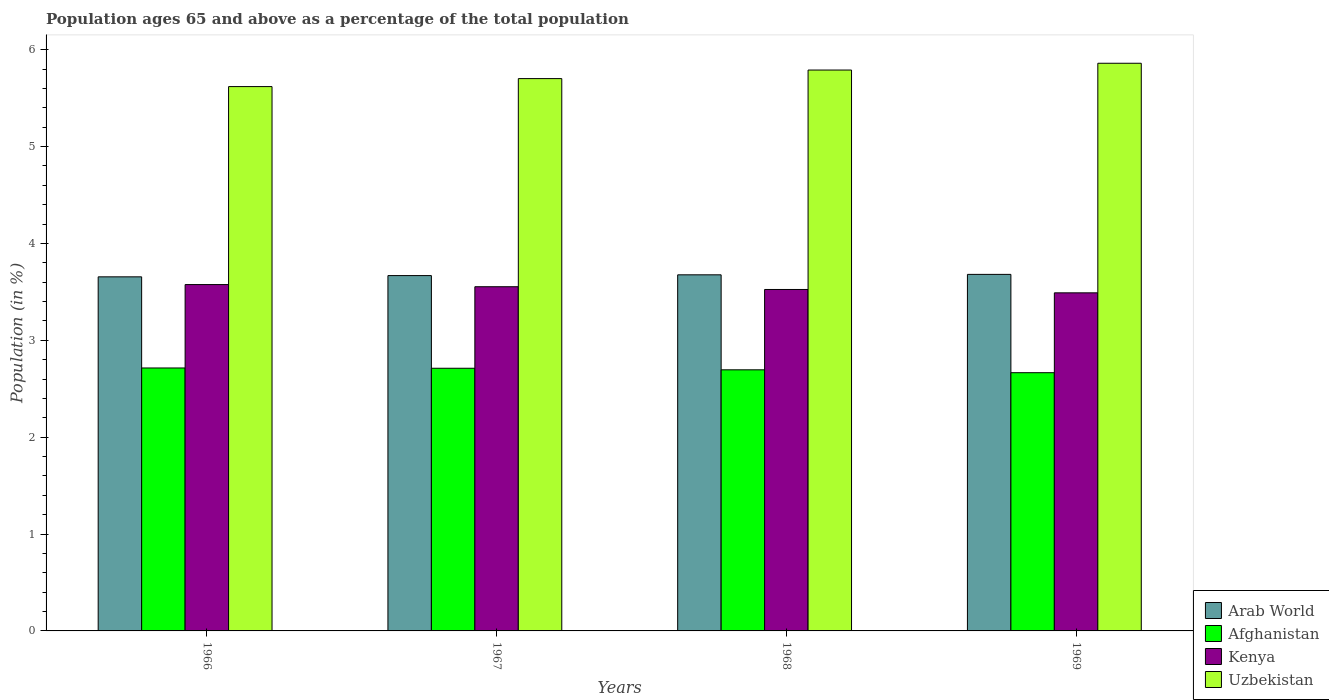How many different coloured bars are there?
Offer a terse response. 4. Are the number of bars on each tick of the X-axis equal?
Provide a short and direct response. Yes. How many bars are there on the 3rd tick from the left?
Your answer should be compact. 4. How many bars are there on the 1st tick from the right?
Provide a succinct answer. 4. What is the label of the 3rd group of bars from the left?
Provide a succinct answer. 1968. In how many cases, is the number of bars for a given year not equal to the number of legend labels?
Your answer should be compact. 0. What is the percentage of the population ages 65 and above in Afghanistan in 1968?
Offer a terse response. 2.7. Across all years, what is the maximum percentage of the population ages 65 and above in Uzbekistan?
Give a very brief answer. 5.86. Across all years, what is the minimum percentage of the population ages 65 and above in Uzbekistan?
Your answer should be compact. 5.62. In which year was the percentage of the population ages 65 and above in Uzbekistan maximum?
Provide a succinct answer. 1969. In which year was the percentage of the population ages 65 and above in Kenya minimum?
Offer a very short reply. 1969. What is the total percentage of the population ages 65 and above in Afghanistan in the graph?
Make the answer very short. 10.79. What is the difference between the percentage of the population ages 65 and above in Uzbekistan in 1966 and that in 1969?
Offer a terse response. -0.24. What is the difference between the percentage of the population ages 65 and above in Arab World in 1968 and the percentage of the population ages 65 and above in Uzbekistan in 1967?
Provide a short and direct response. -2.03. What is the average percentage of the population ages 65 and above in Afghanistan per year?
Ensure brevity in your answer.  2.7. In the year 1968, what is the difference between the percentage of the population ages 65 and above in Arab World and percentage of the population ages 65 and above in Kenya?
Your response must be concise. 0.15. What is the ratio of the percentage of the population ages 65 and above in Uzbekistan in 1966 to that in 1968?
Provide a succinct answer. 0.97. Is the percentage of the population ages 65 and above in Afghanistan in 1966 less than that in 1968?
Your answer should be compact. No. What is the difference between the highest and the second highest percentage of the population ages 65 and above in Arab World?
Your response must be concise. 0. What is the difference between the highest and the lowest percentage of the population ages 65 and above in Afghanistan?
Your response must be concise. 0.05. Is the sum of the percentage of the population ages 65 and above in Arab World in 1966 and 1967 greater than the maximum percentage of the population ages 65 and above in Kenya across all years?
Make the answer very short. Yes. Is it the case that in every year, the sum of the percentage of the population ages 65 and above in Arab World and percentage of the population ages 65 and above in Uzbekistan is greater than the sum of percentage of the population ages 65 and above in Afghanistan and percentage of the population ages 65 and above in Kenya?
Make the answer very short. Yes. What does the 4th bar from the left in 1967 represents?
Your answer should be compact. Uzbekistan. What does the 1st bar from the right in 1967 represents?
Your answer should be compact. Uzbekistan. Is it the case that in every year, the sum of the percentage of the population ages 65 and above in Kenya and percentage of the population ages 65 and above in Arab World is greater than the percentage of the population ages 65 and above in Uzbekistan?
Your answer should be compact. Yes. Are all the bars in the graph horizontal?
Give a very brief answer. No. What is the difference between two consecutive major ticks on the Y-axis?
Provide a short and direct response. 1. Does the graph contain any zero values?
Give a very brief answer. No. How are the legend labels stacked?
Your answer should be compact. Vertical. What is the title of the graph?
Provide a succinct answer. Population ages 65 and above as a percentage of the total population. What is the label or title of the X-axis?
Ensure brevity in your answer.  Years. What is the label or title of the Y-axis?
Provide a short and direct response. Population (in %). What is the Population (in %) of Arab World in 1966?
Ensure brevity in your answer.  3.66. What is the Population (in %) of Afghanistan in 1966?
Offer a very short reply. 2.71. What is the Population (in %) of Kenya in 1966?
Offer a very short reply. 3.58. What is the Population (in %) of Uzbekistan in 1966?
Offer a very short reply. 5.62. What is the Population (in %) in Arab World in 1967?
Provide a short and direct response. 3.67. What is the Population (in %) in Afghanistan in 1967?
Ensure brevity in your answer.  2.71. What is the Population (in %) in Kenya in 1967?
Offer a very short reply. 3.55. What is the Population (in %) in Uzbekistan in 1967?
Offer a terse response. 5.7. What is the Population (in %) of Arab World in 1968?
Ensure brevity in your answer.  3.68. What is the Population (in %) in Afghanistan in 1968?
Provide a succinct answer. 2.7. What is the Population (in %) of Kenya in 1968?
Your answer should be compact. 3.52. What is the Population (in %) of Uzbekistan in 1968?
Give a very brief answer. 5.79. What is the Population (in %) of Arab World in 1969?
Provide a succinct answer. 3.68. What is the Population (in %) of Afghanistan in 1969?
Provide a succinct answer. 2.67. What is the Population (in %) in Kenya in 1969?
Give a very brief answer. 3.49. What is the Population (in %) in Uzbekistan in 1969?
Ensure brevity in your answer.  5.86. Across all years, what is the maximum Population (in %) of Arab World?
Your answer should be very brief. 3.68. Across all years, what is the maximum Population (in %) in Afghanistan?
Provide a succinct answer. 2.71. Across all years, what is the maximum Population (in %) of Kenya?
Your answer should be very brief. 3.58. Across all years, what is the maximum Population (in %) in Uzbekistan?
Ensure brevity in your answer.  5.86. Across all years, what is the minimum Population (in %) of Arab World?
Give a very brief answer. 3.66. Across all years, what is the minimum Population (in %) of Afghanistan?
Offer a terse response. 2.67. Across all years, what is the minimum Population (in %) of Kenya?
Offer a very short reply. 3.49. Across all years, what is the minimum Population (in %) of Uzbekistan?
Offer a very short reply. 5.62. What is the total Population (in %) of Arab World in the graph?
Provide a short and direct response. 14.68. What is the total Population (in %) in Afghanistan in the graph?
Your answer should be very brief. 10.79. What is the total Population (in %) in Kenya in the graph?
Give a very brief answer. 14.14. What is the total Population (in %) of Uzbekistan in the graph?
Offer a very short reply. 22.97. What is the difference between the Population (in %) of Arab World in 1966 and that in 1967?
Offer a terse response. -0.01. What is the difference between the Population (in %) of Afghanistan in 1966 and that in 1967?
Provide a succinct answer. 0. What is the difference between the Population (in %) in Kenya in 1966 and that in 1967?
Give a very brief answer. 0.02. What is the difference between the Population (in %) in Uzbekistan in 1966 and that in 1967?
Offer a very short reply. -0.08. What is the difference between the Population (in %) in Arab World in 1966 and that in 1968?
Your answer should be compact. -0.02. What is the difference between the Population (in %) of Afghanistan in 1966 and that in 1968?
Provide a short and direct response. 0.02. What is the difference between the Population (in %) in Kenya in 1966 and that in 1968?
Offer a terse response. 0.05. What is the difference between the Population (in %) in Uzbekistan in 1966 and that in 1968?
Provide a short and direct response. -0.17. What is the difference between the Population (in %) of Arab World in 1966 and that in 1969?
Your answer should be very brief. -0.03. What is the difference between the Population (in %) of Afghanistan in 1966 and that in 1969?
Offer a very short reply. 0.05. What is the difference between the Population (in %) of Kenya in 1966 and that in 1969?
Make the answer very short. 0.09. What is the difference between the Population (in %) in Uzbekistan in 1966 and that in 1969?
Your answer should be very brief. -0.24. What is the difference between the Population (in %) in Arab World in 1967 and that in 1968?
Your response must be concise. -0.01. What is the difference between the Population (in %) of Afghanistan in 1967 and that in 1968?
Provide a succinct answer. 0.02. What is the difference between the Population (in %) of Kenya in 1967 and that in 1968?
Provide a succinct answer. 0.03. What is the difference between the Population (in %) in Uzbekistan in 1967 and that in 1968?
Keep it short and to the point. -0.09. What is the difference between the Population (in %) of Arab World in 1967 and that in 1969?
Ensure brevity in your answer.  -0.01. What is the difference between the Population (in %) of Afghanistan in 1967 and that in 1969?
Ensure brevity in your answer.  0.05. What is the difference between the Population (in %) of Kenya in 1967 and that in 1969?
Your answer should be compact. 0.06. What is the difference between the Population (in %) of Uzbekistan in 1967 and that in 1969?
Your answer should be very brief. -0.16. What is the difference between the Population (in %) of Arab World in 1968 and that in 1969?
Offer a very short reply. -0. What is the difference between the Population (in %) of Afghanistan in 1968 and that in 1969?
Provide a succinct answer. 0.03. What is the difference between the Population (in %) of Kenya in 1968 and that in 1969?
Give a very brief answer. 0.03. What is the difference between the Population (in %) in Uzbekistan in 1968 and that in 1969?
Offer a very short reply. -0.07. What is the difference between the Population (in %) of Arab World in 1966 and the Population (in %) of Afghanistan in 1967?
Your response must be concise. 0.94. What is the difference between the Population (in %) of Arab World in 1966 and the Population (in %) of Kenya in 1967?
Offer a very short reply. 0.1. What is the difference between the Population (in %) in Arab World in 1966 and the Population (in %) in Uzbekistan in 1967?
Your answer should be compact. -2.05. What is the difference between the Population (in %) in Afghanistan in 1966 and the Population (in %) in Kenya in 1967?
Provide a succinct answer. -0.84. What is the difference between the Population (in %) in Afghanistan in 1966 and the Population (in %) in Uzbekistan in 1967?
Your answer should be very brief. -2.99. What is the difference between the Population (in %) in Kenya in 1966 and the Population (in %) in Uzbekistan in 1967?
Ensure brevity in your answer.  -2.13. What is the difference between the Population (in %) of Arab World in 1966 and the Population (in %) of Afghanistan in 1968?
Provide a succinct answer. 0.96. What is the difference between the Population (in %) in Arab World in 1966 and the Population (in %) in Kenya in 1968?
Make the answer very short. 0.13. What is the difference between the Population (in %) in Arab World in 1966 and the Population (in %) in Uzbekistan in 1968?
Your response must be concise. -2.13. What is the difference between the Population (in %) in Afghanistan in 1966 and the Population (in %) in Kenya in 1968?
Offer a terse response. -0.81. What is the difference between the Population (in %) of Afghanistan in 1966 and the Population (in %) of Uzbekistan in 1968?
Provide a succinct answer. -3.08. What is the difference between the Population (in %) of Kenya in 1966 and the Population (in %) of Uzbekistan in 1968?
Make the answer very short. -2.21. What is the difference between the Population (in %) of Arab World in 1966 and the Population (in %) of Afghanistan in 1969?
Your answer should be very brief. 0.99. What is the difference between the Population (in %) of Arab World in 1966 and the Population (in %) of Kenya in 1969?
Provide a succinct answer. 0.17. What is the difference between the Population (in %) of Arab World in 1966 and the Population (in %) of Uzbekistan in 1969?
Offer a terse response. -2.2. What is the difference between the Population (in %) in Afghanistan in 1966 and the Population (in %) in Kenya in 1969?
Your answer should be very brief. -0.78. What is the difference between the Population (in %) in Afghanistan in 1966 and the Population (in %) in Uzbekistan in 1969?
Your response must be concise. -3.15. What is the difference between the Population (in %) in Kenya in 1966 and the Population (in %) in Uzbekistan in 1969?
Give a very brief answer. -2.28. What is the difference between the Population (in %) of Arab World in 1967 and the Population (in %) of Afghanistan in 1968?
Offer a terse response. 0.97. What is the difference between the Population (in %) in Arab World in 1967 and the Population (in %) in Kenya in 1968?
Offer a very short reply. 0.14. What is the difference between the Population (in %) in Arab World in 1967 and the Population (in %) in Uzbekistan in 1968?
Ensure brevity in your answer.  -2.12. What is the difference between the Population (in %) of Afghanistan in 1967 and the Population (in %) of Kenya in 1968?
Your response must be concise. -0.81. What is the difference between the Population (in %) of Afghanistan in 1967 and the Population (in %) of Uzbekistan in 1968?
Your response must be concise. -3.08. What is the difference between the Population (in %) in Kenya in 1967 and the Population (in %) in Uzbekistan in 1968?
Give a very brief answer. -2.24. What is the difference between the Population (in %) of Arab World in 1967 and the Population (in %) of Afghanistan in 1969?
Your response must be concise. 1. What is the difference between the Population (in %) in Arab World in 1967 and the Population (in %) in Kenya in 1969?
Make the answer very short. 0.18. What is the difference between the Population (in %) of Arab World in 1967 and the Population (in %) of Uzbekistan in 1969?
Your answer should be very brief. -2.19. What is the difference between the Population (in %) in Afghanistan in 1967 and the Population (in %) in Kenya in 1969?
Provide a short and direct response. -0.78. What is the difference between the Population (in %) in Afghanistan in 1967 and the Population (in %) in Uzbekistan in 1969?
Your response must be concise. -3.15. What is the difference between the Population (in %) in Kenya in 1967 and the Population (in %) in Uzbekistan in 1969?
Your answer should be compact. -2.31. What is the difference between the Population (in %) in Arab World in 1968 and the Population (in %) in Afghanistan in 1969?
Keep it short and to the point. 1.01. What is the difference between the Population (in %) of Arab World in 1968 and the Population (in %) of Kenya in 1969?
Offer a terse response. 0.19. What is the difference between the Population (in %) of Arab World in 1968 and the Population (in %) of Uzbekistan in 1969?
Your response must be concise. -2.18. What is the difference between the Population (in %) of Afghanistan in 1968 and the Population (in %) of Kenya in 1969?
Give a very brief answer. -0.79. What is the difference between the Population (in %) in Afghanistan in 1968 and the Population (in %) in Uzbekistan in 1969?
Give a very brief answer. -3.16. What is the difference between the Population (in %) in Kenya in 1968 and the Population (in %) in Uzbekistan in 1969?
Your answer should be compact. -2.34. What is the average Population (in %) of Arab World per year?
Provide a succinct answer. 3.67. What is the average Population (in %) in Afghanistan per year?
Provide a succinct answer. 2.7. What is the average Population (in %) in Kenya per year?
Give a very brief answer. 3.54. What is the average Population (in %) in Uzbekistan per year?
Give a very brief answer. 5.74. In the year 1966, what is the difference between the Population (in %) of Arab World and Population (in %) of Afghanistan?
Your answer should be very brief. 0.94. In the year 1966, what is the difference between the Population (in %) in Arab World and Population (in %) in Kenya?
Provide a succinct answer. 0.08. In the year 1966, what is the difference between the Population (in %) in Arab World and Population (in %) in Uzbekistan?
Your answer should be compact. -1.96. In the year 1966, what is the difference between the Population (in %) in Afghanistan and Population (in %) in Kenya?
Keep it short and to the point. -0.86. In the year 1966, what is the difference between the Population (in %) in Afghanistan and Population (in %) in Uzbekistan?
Give a very brief answer. -2.9. In the year 1966, what is the difference between the Population (in %) in Kenya and Population (in %) in Uzbekistan?
Provide a succinct answer. -2.04. In the year 1967, what is the difference between the Population (in %) in Arab World and Population (in %) in Afghanistan?
Offer a very short reply. 0.96. In the year 1967, what is the difference between the Population (in %) in Arab World and Population (in %) in Kenya?
Provide a succinct answer. 0.12. In the year 1967, what is the difference between the Population (in %) in Arab World and Population (in %) in Uzbekistan?
Your answer should be compact. -2.03. In the year 1967, what is the difference between the Population (in %) in Afghanistan and Population (in %) in Kenya?
Give a very brief answer. -0.84. In the year 1967, what is the difference between the Population (in %) in Afghanistan and Population (in %) in Uzbekistan?
Keep it short and to the point. -2.99. In the year 1967, what is the difference between the Population (in %) in Kenya and Population (in %) in Uzbekistan?
Your answer should be very brief. -2.15. In the year 1968, what is the difference between the Population (in %) of Arab World and Population (in %) of Afghanistan?
Ensure brevity in your answer.  0.98. In the year 1968, what is the difference between the Population (in %) in Arab World and Population (in %) in Kenya?
Provide a succinct answer. 0.15. In the year 1968, what is the difference between the Population (in %) of Arab World and Population (in %) of Uzbekistan?
Keep it short and to the point. -2.11. In the year 1968, what is the difference between the Population (in %) of Afghanistan and Population (in %) of Kenya?
Your response must be concise. -0.83. In the year 1968, what is the difference between the Population (in %) of Afghanistan and Population (in %) of Uzbekistan?
Offer a terse response. -3.09. In the year 1968, what is the difference between the Population (in %) of Kenya and Population (in %) of Uzbekistan?
Offer a terse response. -2.27. In the year 1969, what is the difference between the Population (in %) in Arab World and Population (in %) in Afghanistan?
Your answer should be very brief. 1.01. In the year 1969, what is the difference between the Population (in %) of Arab World and Population (in %) of Kenya?
Offer a very short reply. 0.19. In the year 1969, what is the difference between the Population (in %) in Arab World and Population (in %) in Uzbekistan?
Your response must be concise. -2.18. In the year 1969, what is the difference between the Population (in %) of Afghanistan and Population (in %) of Kenya?
Ensure brevity in your answer.  -0.82. In the year 1969, what is the difference between the Population (in %) in Afghanistan and Population (in %) in Uzbekistan?
Your response must be concise. -3.19. In the year 1969, what is the difference between the Population (in %) in Kenya and Population (in %) in Uzbekistan?
Keep it short and to the point. -2.37. What is the ratio of the Population (in %) in Arab World in 1966 to that in 1967?
Your answer should be very brief. 1. What is the ratio of the Population (in %) of Uzbekistan in 1966 to that in 1967?
Ensure brevity in your answer.  0.99. What is the ratio of the Population (in %) of Arab World in 1966 to that in 1968?
Ensure brevity in your answer.  0.99. What is the ratio of the Population (in %) in Afghanistan in 1966 to that in 1968?
Offer a terse response. 1.01. What is the ratio of the Population (in %) of Kenya in 1966 to that in 1968?
Make the answer very short. 1.01. What is the ratio of the Population (in %) of Uzbekistan in 1966 to that in 1968?
Offer a very short reply. 0.97. What is the ratio of the Population (in %) in Afghanistan in 1966 to that in 1969?
Your response must be concise. 1.02. What is the ratio of the Population (in %) in Kenya in 1966 to that in 1969?
Give a very brief answer. 1.02. What is the ratio of the Population (in %) of Uzbekistan in 1966 to that in 1969?
Offer a terse response. 0.96. What is the ratio of the Population (in %) in Arab World in 1967 to that in 1968?
Keep it short and to the point. 1. What is the ratio of the Population (in %) of Kenya in 1967 to that in 1968?
Make the answer very short. 1.01. What is the ratio of the Population (in %) of Uzbekistan in 1967 to that in 1968?
Offer a very short reply. 0.98. What is the ratio of the Population (in %) of Arab World in 1967 to that in 1969?
Your response must be concise. 1. What is the ratio of the Population (in %) of Afghanistan in 1967 to that in 1969?
Your response must be concise. 1.02. What is the ratio of the Population (in %) of Kenya in 1967 to that in 1969?
Provide a succinct answer. 1.02. What is the ratio of the Population (in %) of Uzbekistan in 1967 to that in 1969?
Make the answer very short. 0.97. What is the ratio of the Population (in %) of Afghanistan in 1968 to that in 1969?
Your answer should be compact. 1.01. What is the ratio of the Population (in %) of Uzbekistan in 1968 to that in 1969?
Provide a succinct answer. 0.99. What is the difference between the highest and the second highest Population (in %) of Arab World?
Your response must be concise. 0. What is the difference between the highest and the second highest Population (in %) of Afghanistan?
Your answer should be compact. 0. What is the difference between the highest and the second highest Population (in %) in Kenya?
Give a very brief answer. 0.02. What is the difference between the highest and the second highest Population (in %) of Uzbekistan?
Offer a terse response. 0.07. What is the difference between the highest and the lowest Population (in %) of Arab World?
Keep it short and to the point. 0.03. What is the difference between the highest and the lowest Population (in %) in Afghanistan?
Make the answer very short. 0.05. What is the difference between the highest and the lowest Population (in %) in Kenya?
Offer a terse response. 0.09. What is the difference between the highest and the lowest Population (in %) of Uzbekistan?
Provide a succinct answer. 0.24. 